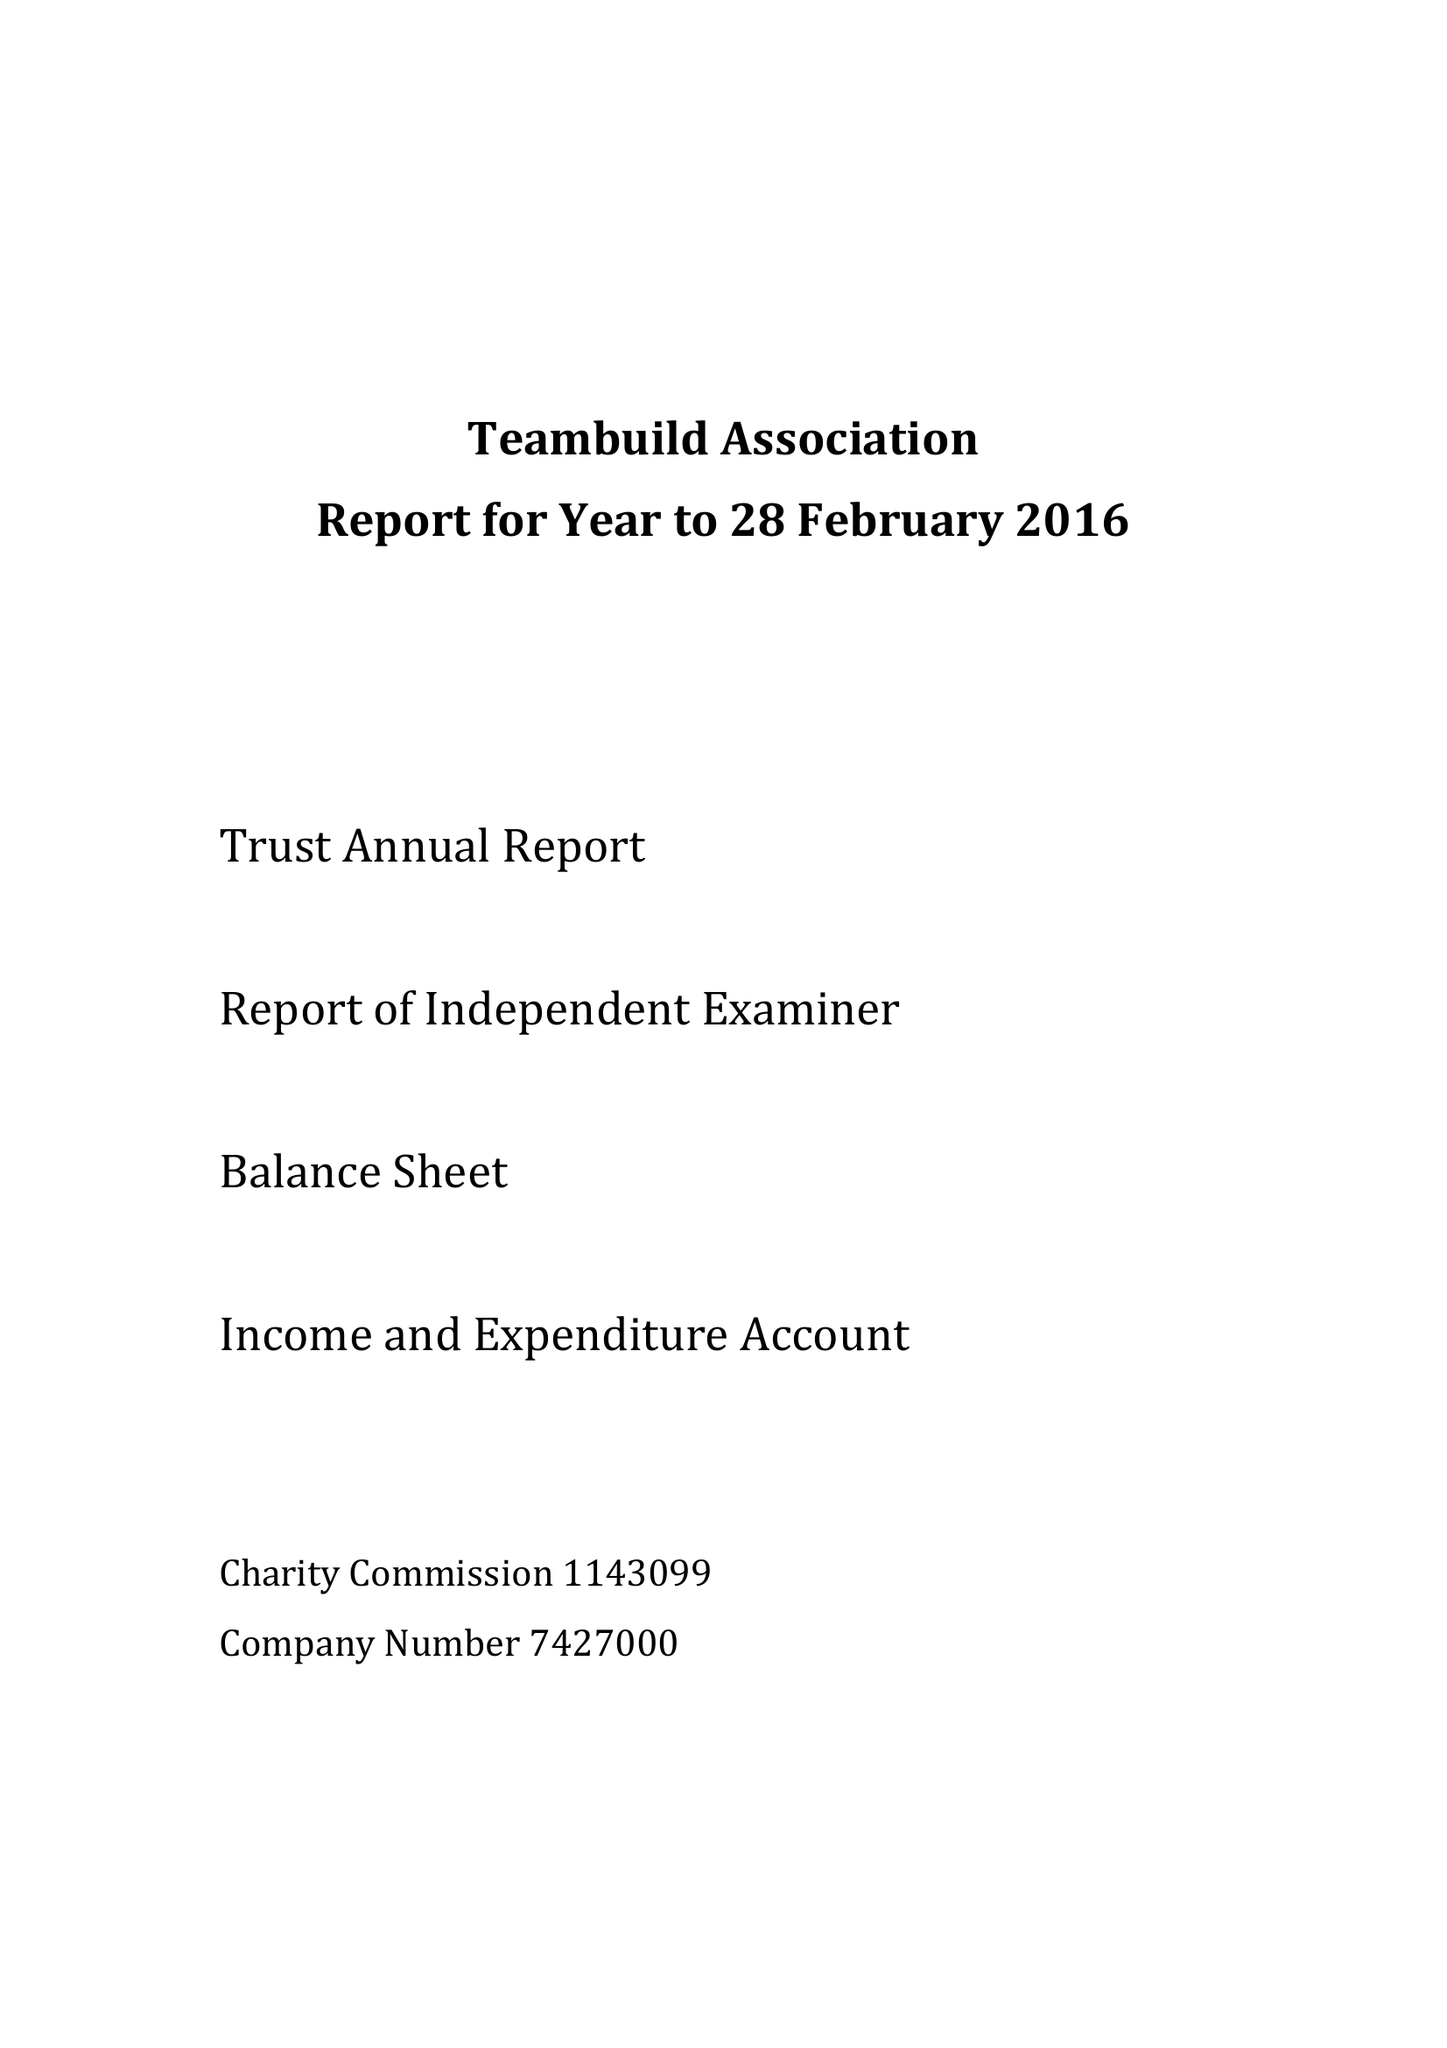What is the value for the spending_annually_in_british_pounds?
Answer the question using a single word or phrase. 60033.00 